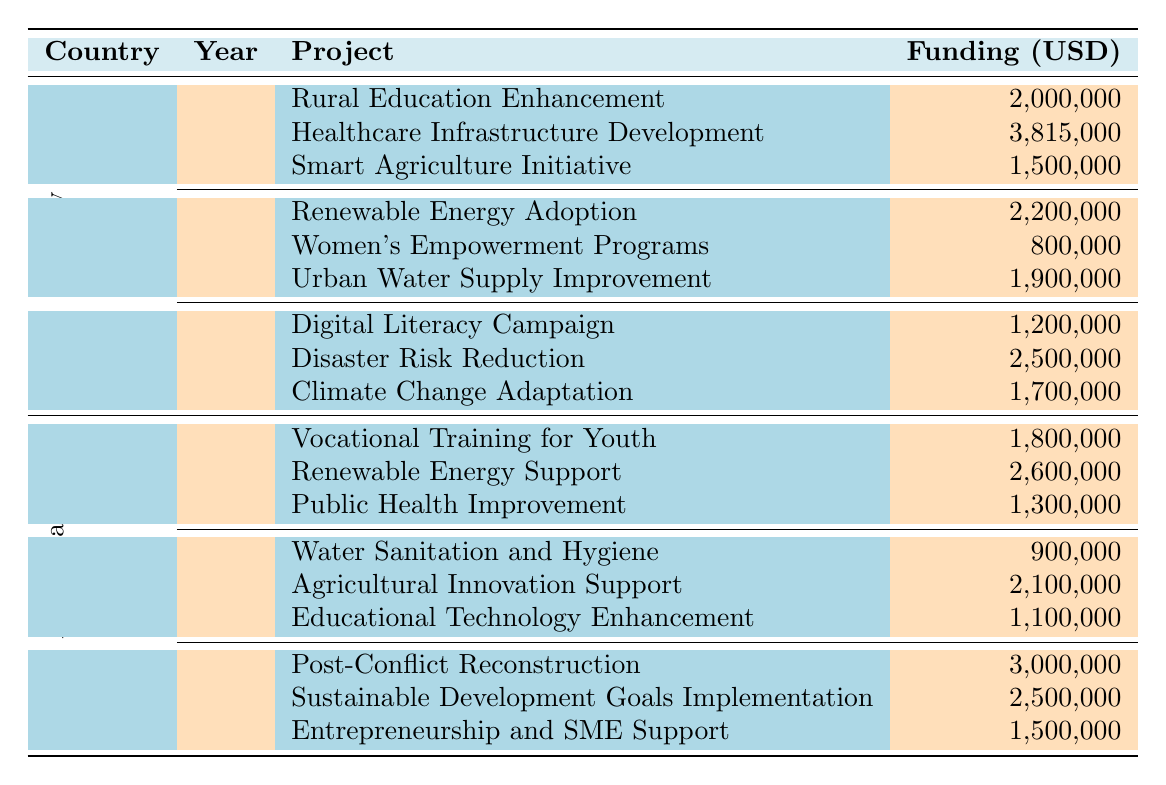What is the total funding amount for projects in Turkey in 2021? In 2021, the funding amounts for Turkey's projects are: Rural Education Enhancement (2,000,000), Healthcare Infrastructure Development (3,815,000), and Smart Agriculture Initiative (1,500,000). Adding these amounts together gives: 2,000,000 + 3,815,000 + 1,500,000 = 7,315,000.
Answer: 7,315,000 Which organization funded the "Digital Literacy Campaign" in Turkey in 2023? The "Digital Literacy Campaign" in Turkey in 2023 was funded by the Bill & Melinda Gates Foundation, as shown in the table.
Answer: Bill & Melinda Gates Foundation Is the total funding for Azerbaijan in 2022 greater than in 2021? The total funding for Azerbaijan in 2021 is: Vocational Training for Youth (1,800,000), Renewable Energy Support (2,600,000), and Public Health Improvement (1,300,000), totaling 5,700,000. In 2022, the projects are: Water Sanitation and Hygiene (900,000), Agricultural Innovation Support (2,100,000), and Educational Technology Enhancement (1,100,000), totaling 4,100,000. Since 5,700,000 > 4,100,000, the statement is true.
Answer: Yes What is the average funding amount per project in Turkey for the year 2022? The total funding amounts for Turkey in 2022 are Renewable Energy Adoption (2,200,000), Women's Empowerment Programs (800,000), and Urban Water Supply Improvement (1,900,000), totaling 4,900,000. There are 3 projects, so the average is 4,900,000 / 3 = 1,633,333.33.
Answer: 1,633,333.33 Did the amount funded by the European Union in Turkey in 2021 exceed 3 million USD? The amount funded by the European Union in Turkey in 2021 for Healthcare Infrastructure Development is 3,815,000. Since 3,815,000 > 3,000,000, the statement is true.
Answer: Yes What is the funding difference between the highest and lowest funded projects in Azerbaijan in 2023? In 2023, the projects in Azerbaijan are: Post-Conflict Reconstruction (3,000,000), Sustainable Development Goals Implementation (2,500,000), and Entrepreneurship and SME Support (1,500,000). The highest funded project is 3,000,000 and the lowest is 1,500,000. The difference is 3,000,000 - 1,500,000 = 1,500,000.
Answer: 1,500,000 Which year had the highest total funding for Turkey? The total funding for Turkey over the years are as follows: 2021 = 7,315,000, 2022 = 4,900,000, and 2023 = 4,400,000. The highest total funding is in 2021 with 7,315,000, making it the year with the highest funding.
Answer: 2021 How much funding did the World Bank provide across both countries in 2021? In 2021, for Turkey, the World Bank provided 2,000,000 (Rural Education Enhancement), and for Azerbaijan, the World Bank provided 1,800,000 (Vocational Training for Youth). Adding these gives: 2,000,000 + 1,800,000 = 3,800,000 in total for both countries.
Answer: 3,800,000 